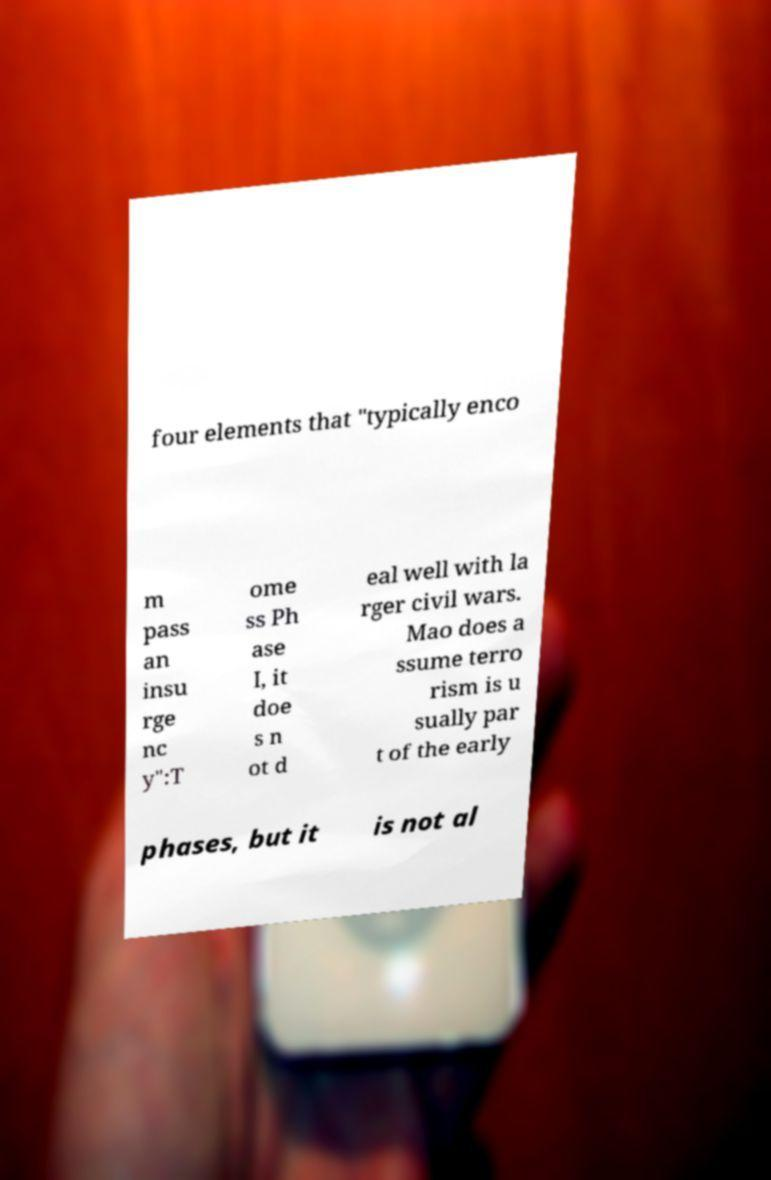Please read and relay the text visible in this image. What does it say? four elements that "typically enco m pass an insu rge nc y":T ome ss Ph ase I, it doe s n ot d eal well with la rger civil wars. Mao does a ssume terro rism is u sually par t of the early phases, but it is not al 